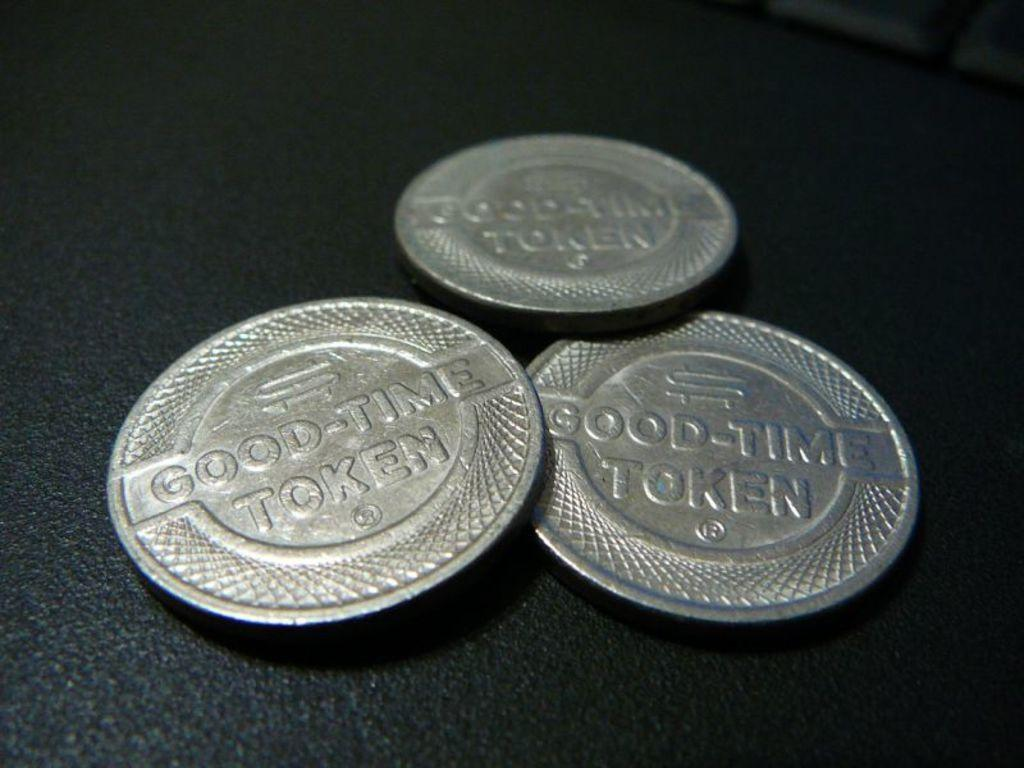<image>
Give a short and clear explanation of the subsequent image. Some silver discs bearing the words good time token 